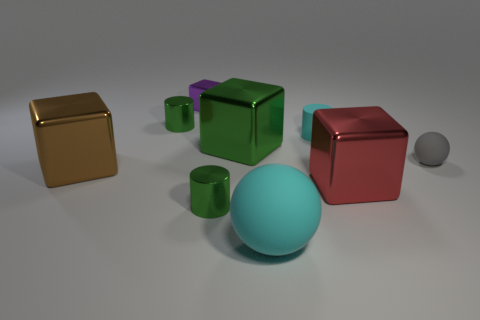Add 1 tiny gray matte cylinders. How many objects exist? 10 Subtract all cubes. How many objects are left? 5 Subtract all red blocks. Subtract all green blocks. How many objects are left? 7 Add 6 small purple metallic things. How many small purple metallic things are left? 7 Add 4 rubber cylinders. How many rubber cylinders exist? 5 Subtract 0 brown balls. How many objects are left? 9 